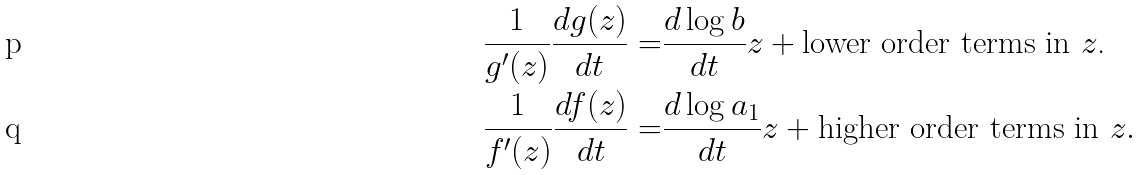<formula> <loc_0><loc_0><loc_500><loc_500>\frac { 1 } { g ^ { \prime } ( z ) } \frac { d g ( z ) } { d t } = & \frac { d \log b } { d t } z + \text {lower order terms in $z$.} \\ \frac { 1 } { f ^ { \prime } ( z ) } \frac { d f ( z ) } { d t } = & \frac { d \log a _ { 1 } } { d t } z + \text {higher order terms in $z$} .</formula> 